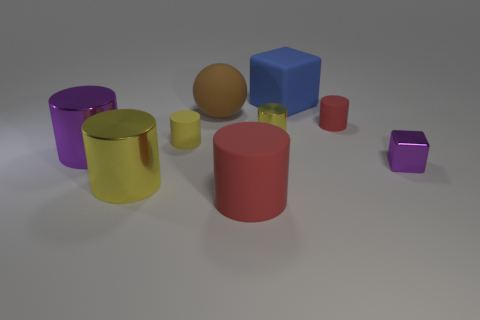How many yellow cylinders must be subtracted to get 1 yellow cylinders? 2 Subtract all cyan cubes. How many yellow cylinders are left? 3 Subtract 2 cylinders. How many cylinders are left? 4 Subtract all purple cylinders. How many cylinders are left? 5 Subtract all purple cylinders. How many cylinders are left? 5 Subtract all green cylinders. Subtract all yellow balls. How many cylinders are left? 6 Add 1 blue metal objects. How many objects exist? 10 Subtract all spheres. How many objects are left? 8 Subtract 2 red cylinders. How many objects are left? 7 Subtract all gray balls. Subtract all large blue cubes. How many objects are left? 8 